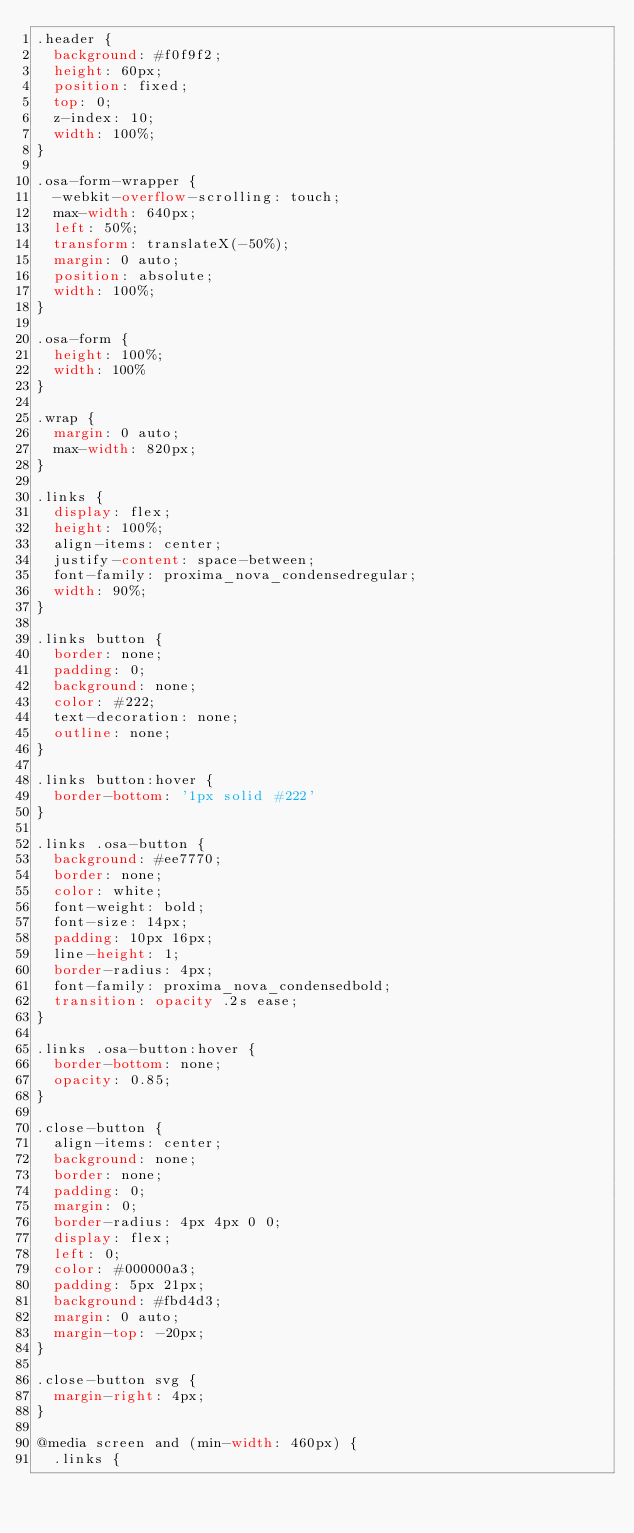<code> <loc_0><loc_0><loc_500><loc_500><_CSS_>.header {
  background: #f0f9f2;
  height: 60px;
  position: fixed;
  top: 0;
  z-index: 10;
  width: 100%;
}

.osa-form-wrapper {
  -webkit-overflow-scrolling: touch;
  max-width: 640px;
  left: 50%;
  transform: translateX(-50%);
  margin: 0 auto;
  position: absolute;
  width: 100%;
}

.osa-form {
  height: 100%;
  width: 100%
}

.wrap {
  margin: 0 auto;
  max-width: 820px;
}

.links {
  display: flex;
  height: 100%;
  align-items: center;
  justify-content: space-between;
  font-family: proxima_nova_condensedregular;
  width: 90%;
}

.links button {
  border: none;
  padding: 0;
  background: none;
  color: #222;
  text-decoration: none;
  outline: none;
}

.links button:hover {
  border-bottom: '1px solid #222'
}

.links .osa-button {
  background: #ee7770;
  border: none;
  color: white;
  font-weight: bold;
  font-size: 14px;
  padding: 10px 16px;
  line-height: 1;
  border-radius: 4px;
  font-family: proxima_nova_condensedbold;
  transition: opacity .2s ease;
}

.links .osa-button:hover {
  border-bottom: none;
  opacity: 0.85;
}

.close-button {
  align-items: center;
  background: none;
  border: none;
  padding: 0;
  margin: 0;
  border-radius: 4px 4px 0 0;
  display: flex;
  left: 0;
  color: #000000a3;
  padding: 5px 21px;
  background: #fbd4d3;
  margin: 0 auto;
  margin-top: -20px;
}

.close-button svg {
  margin-right: 4px;
}

@media screen and (min-width: 460px) {
  .links {</code> 